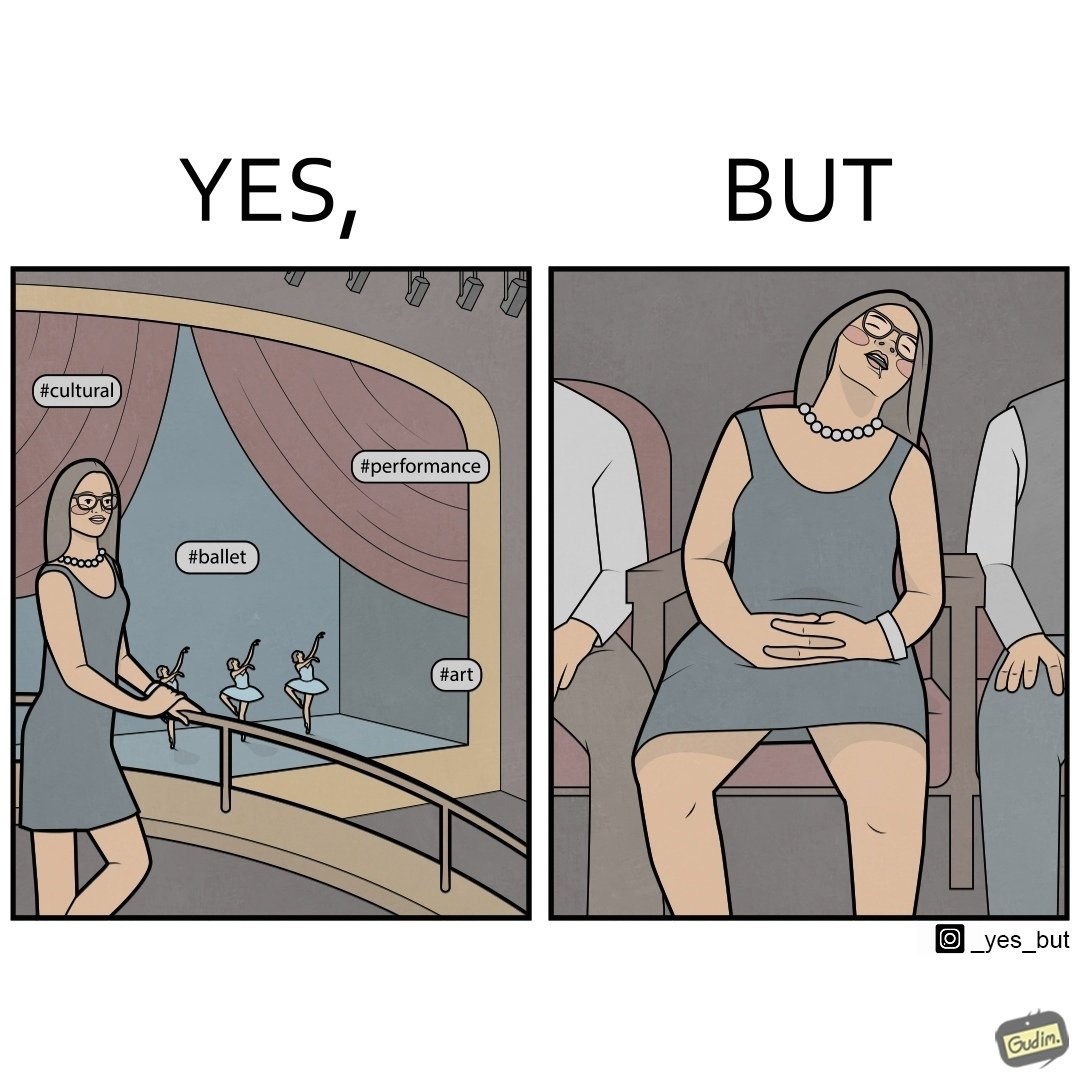What does this image depict? The image is ironic, because in the first image the woman is trying to show off how much she likes ballet dance performance by posting a photo attending some program but in the same program she is seen sleeping on the chair 